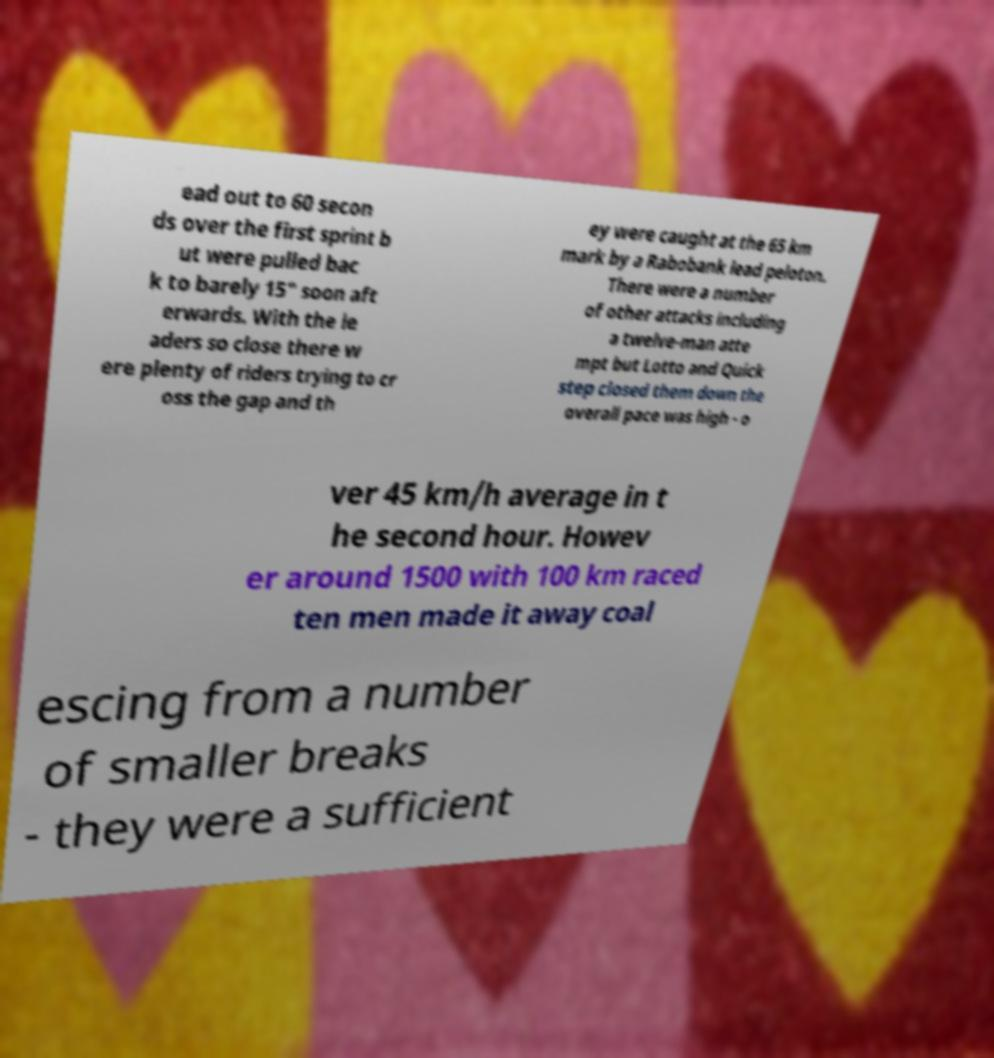There's text embedded in this image that I need extracted. Can you transcribe it verbatim? ead out to 60 secon ds over the first sprint b ut were pulled bac k to barely 15" soon aft erwards. With the le aders so close there w ere plenty of riders trying to cr oss the gap and th ey were caught at the 65 km mark by a Rabobank lead peloton. There were a number of other attacks including a twelve-man atte mpt but Lotto and Quick step closed them down the overall pace was high - o ver 45 km/h average in t he second hour. Howev er around 1500 with 100 km raced ten men made it away coal escing from a number of smaller breaks - they were a sufficient 